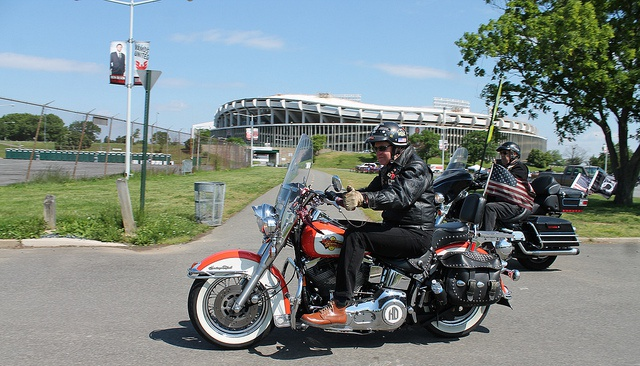Describe the objects in this image and their specific colors. I can see motorcycle in lightblue, black, gray, darkgray, and white tones, people in lightblue, black, gray, darkgray, and blue tones, motorcycle in lightblue, black, gray, blue, and darkgray tones, people in lightblue, black, gray, darkgray, and maroon tones, and car in lightblue, black, gray, and purple tones in this image. 